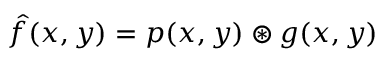<formula> <loc_0><loc_0><loc_500><loc_500>\hat { f } ( x , y ) = p ( x , y ) \circledast g ( x , y )</formula> 